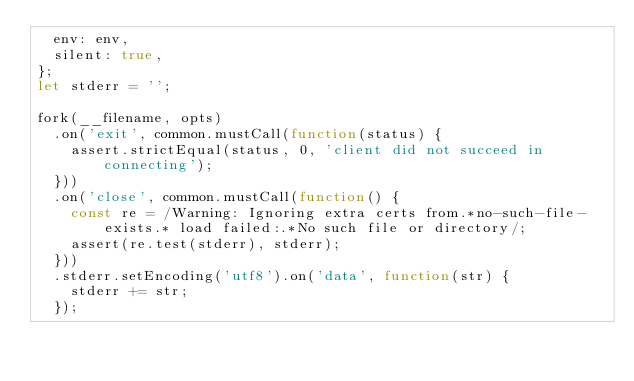Convert code to text. <code><loc_0><loc_0><loc_500><loc_500><_JavaScript_>  env: env,
  silent: true,
};
let stderr = '';

fork(__filename, opts)
  .on('exit', common.mustCall(function(status) {
    assert.strictEqual(status, 0, 'client did not succeed in connecting');
  }))
  .on('close', common.mustCall(function() {
    const re = /Warning: Ignoring extra certs from.*no-such-file-exists.* load failed:.*No such file or directory/;
    assert(re.test(stderr), stderr);
  }))
  .stderr.setEncoding('utf8').on('data', function(str) {
    stderr += str;
  });
</code> 